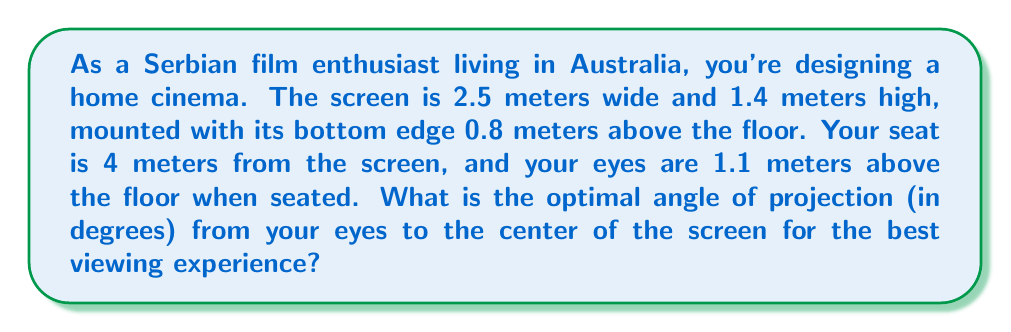Can you solve this math problem? Let's approach this step-by-step:

1) First, we need to find the coordinates of the center of the screen. 
   - The width of the screen doesn't affect our calculation.
   - The height of the screen is 1.4 m, so its center is 0.7 m above its bottom edge.
   - The bottom of the screen is 0.8 m above the floor.
   - Therefore, the center of the screen is 0.8 m + 0.7 m = 1.5 m above the floor.

2) Now we have two points:
   - Your eyes: 4 m from the screen, 1.1 m above the floor
   - Screen center: 0 m from the screen, 1.5 m above the floor

3) We can create a right-angled triangle:
   - The base is 4 m (distance to the screen)
   - The height is 1.5 m - 1.1 m = 0.4 m (difference in height)

4) To find the angle, we use the arctangent function:

   $$\theta = \arctan(\frac{\text{opposite}}{\text{adjacent}}) = \arctan(\frac{0.4}{4})$$

5) Calculate:
   $$\theta = \arctan(0.1) \approx 5.71^\circ$$

[asy]
import geometry;

size(200);

pair A = (0,0);
pair B = (4,0);
pair C = (4,0.4);

draw(A--B--C--A);

label("4 m", (2,0), S);
label("0.4 m", (4,0.2), E);
label("θ", (0.3,0.1), NW);

dot("Eyes", B);
dot("Screen Center", A);
[/asy]
Answer: The optimal angle of projection is approximately $5.71^\circ$. 